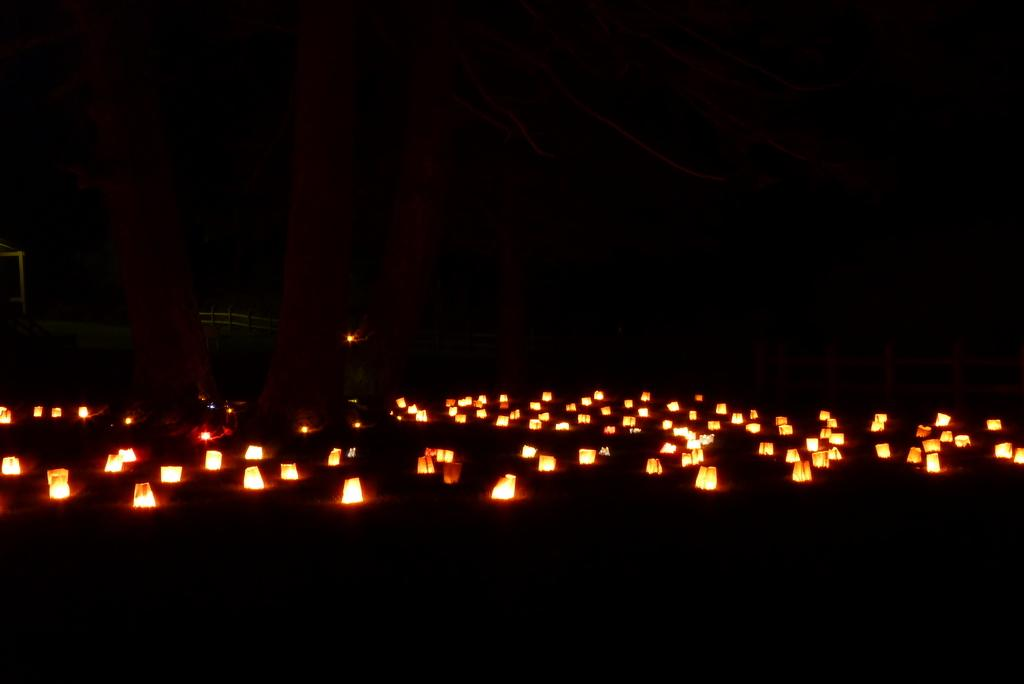What can be seen in the image that provides illumination? There are lights visible in the image. What can be inferred about the environment in which the image was taken? The image was taken in a dark environment. What type of instrument is being played in the image? There is no instrument present in the image. What type of market can be seen in the image? There is no market present in the image. 